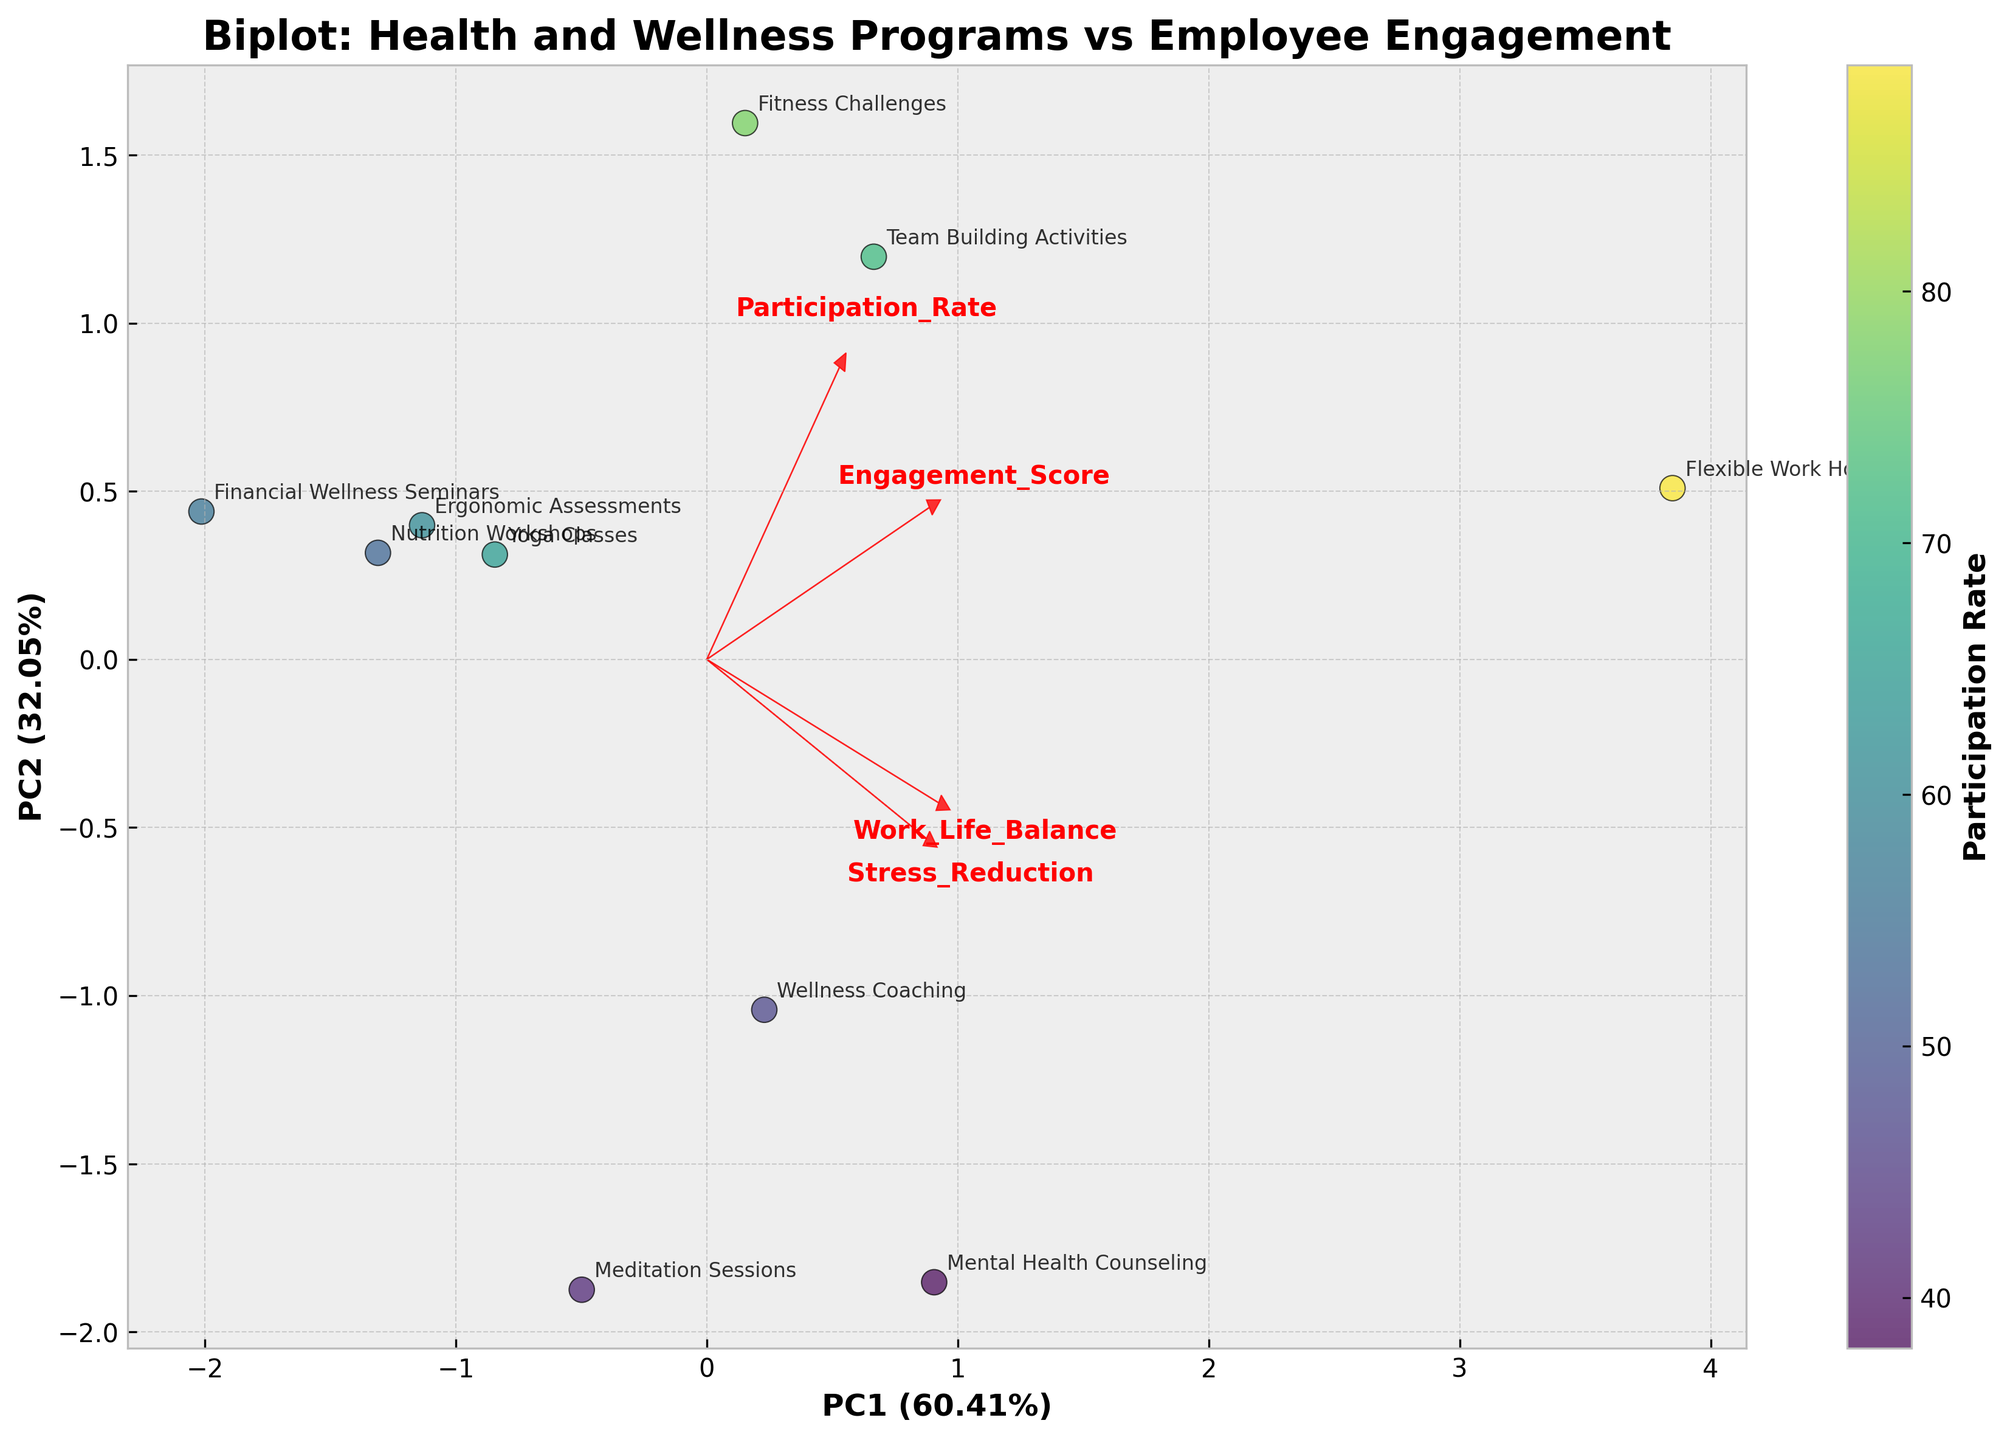What is the title of the figure? The title is usually found at the top of the figure, and in this case, it talks about the content of the plot: "Biplot: Health and Wellness Programs vs Employee Engagement".
Answer: Biplot: Health and Wellness Programs vs Employee Engagement Which health and wellness program has the highest participation rate? From the color shade of the scatter points which are linked to the participation rate color bar legend, the darkest point indicates the highest rate. This corresponds to "Flexible Work Hours".
Answer: Flexible Work Hours What are the axes representing in the biplot? The labels for the axes are found at the bottom and left-hand side of the figure. The x-axis is labeled as "PC1", and the y-axis is labeled as "PC2".
Answer: PC1 and PC2 Which program has the lowest engagement score, and what is its approximate position on the plot? By checking the scatter points and annotations, the position of "Meditation Sessions" is identified and this program has the lowest engagement score of 6.9. It's closer to the lower part of the y-axis.
Answer: Meditation Sessions, lower part of y-axis How do the arrows on the biplot relate to the variables measured? The arrows represent the loadings of each original variable on the principal components. Longer arrows indicate greater importance of that variable in contributing to the variance explained by PC1 and PC2.
Answer: They indicate the direction and importance of variables What can be inferred about the relationship between "Flexible Work Hours" and engagement? The "Flexible Work Hours" point is located far from the origin and in alignment with high loading arrows for "Engagement Score" and "Work-Life Balance", suggesting a strong positive relationship with both.
Answer: Strong positive relationship with engagement and work-life balance Which programs are clustered close together indicating similar characteristics? By observing the proximity of points, "Yoga Classes" and "Ergonomic Assessments" are close together, suggesting similar scores and characteristics in the context of dimensions measured.
Answer: Yoga Classes and Ergonomic Assessments Is there any negative correlation indicated among the measured variables? If arrows of two variables point in nearly opposite directions, it indicates a negative correlation. Here, there is no clear opposite direction among the arrows suggesting no strong negative correlations among variables.
Answer: No strong negative correlation indicated What proportion of the total variance is explained by PC1 and PC2 combined? The proportions are included within the axis labels. For PC1, it is around 54%, and for PC2, it is around 26%. Summing these shares gives us about 80% of the total variance.
Answer: ~80% 